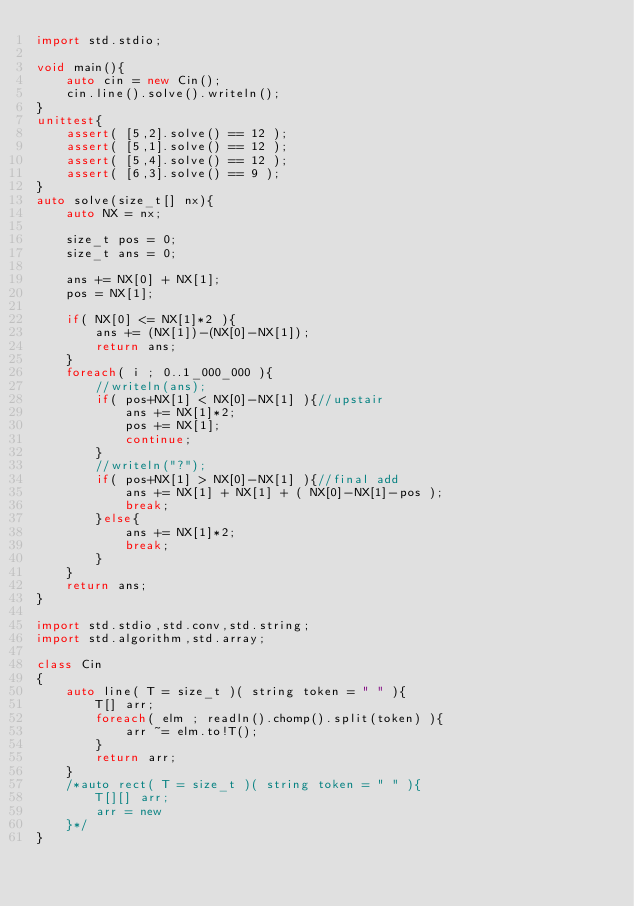Convert code to text. <code><loc_0><loc_0><loc_500><loc_500><_D_>import std.stdio;

void main(){
	auto cin = new Cin();
	cin.line().solve().writeln();
}
unittest{
	assert( [5,2].solve() == 12 );
	assert( [5,1].solve() == 12 );
	assert( [5,4].solve() == 12 );
	assert( [6,3].solve() == 9 );
}
auto solve(size_t[] nx){
	auto NX = nx;
	
	size_t pos = 0;
	size_t ans = 0;
	
	ans += NX[0] + NX[1];
	pos = NX[1];
	
	if( NX[0] <= NX[1]*2 ){
		ans += (NX[1])-(NX[0]-NX[1]);
		return ans;
	}
	foreach( i ; 0..1_000_000 ){
		//writeln(ans);
		if( pos+NX[1] < NX[0]-NX[1] ){//upstair
			ans += NX[1]*2;
			pos += NX[1];
			continue;
		}
		//writeln("?");
		if( pos+NX[1] > NX[0]-NX[1] ){//final add
			ans += NX[1] + NX[1] + ( NX[0]-NX[1]-pos );
			break;
		}else{
			ans += NX[1]*2;
			break;
		}
	}
	return ans;
}

import std.stdio,std.conv,std.string;
import std.algorithm,std.array;

class Cin
{
	auto line( T = size_t )( string token = " " ){
		T[] arr;
		foreach( elm ; readln().chomp().split(token) ){
			arr ~= elm.to!T();
		}
		return arr;
	}
	/*auto rect( T = size_t )( string token = " " ){
		T[][] arr;
		arr = new
	}*/
}
</code> 